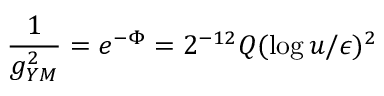<formula> <loc_0><loc_0><loc_500><loc_500>{ \frac { 1 } { g _ { Y M } ^ { 2 } } } = e ^ { - \Phi } = 2 ^ { - 1 2 } Q ( \log { u / \epsilon } ) ^ { 2 }</formula> 